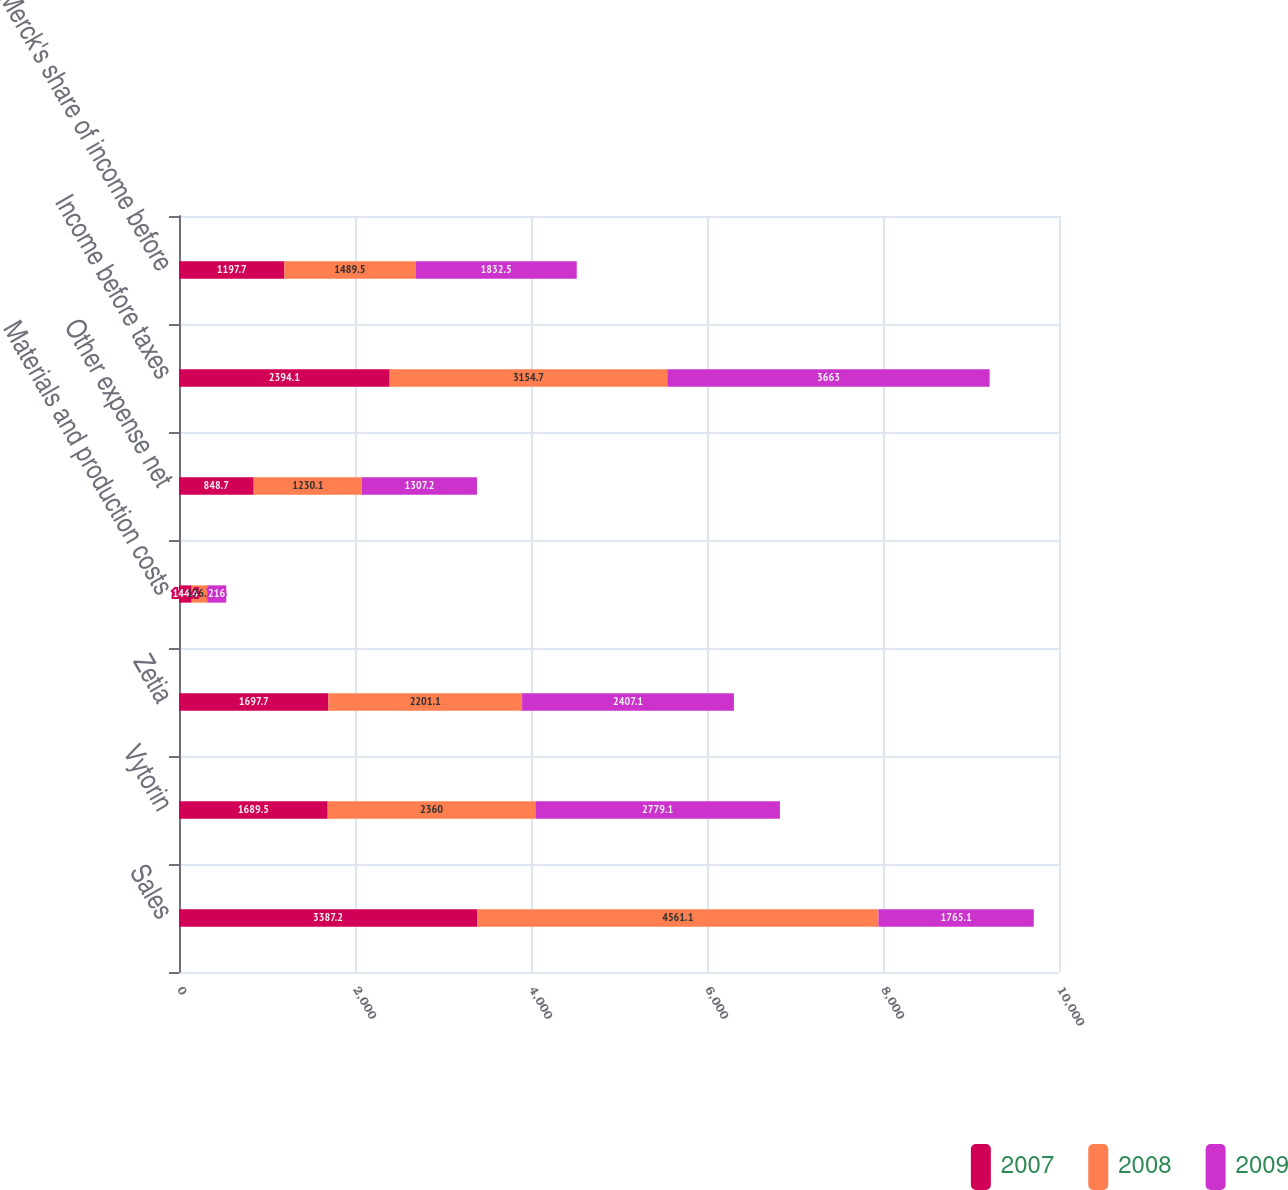Convert chart. <chart><loc_0><loc_0><loc_500><loc_500><stacked_bar_chart><ecel><fcel>Sales<fcel>Vytorin<fcel>Zetia<fcel>Materials and production costs<fcel>Other expense net<fcel>Income before taxes<fcel>Merck's share of income before<nl><fcel>2007<fcel>3387.2<fcel>1689.5<fcel>1697.7<fcel>144.4<fcel>848.7<fcel>2394.1<fcel>1197.7<nl><fcel>2008<fcel>4561.1<fcel>2360<fcel>2201.1<fcel>176.3<fcel>1230.1<fcel>3154.7<fcel>1489.5<nl><fcel>2009<fcel>1765.1<fcel>2779.1<fcel>2407.1<fcel>216<fcel>1307.2<fcel>3663<fcel>1832.5<nl></chart> 